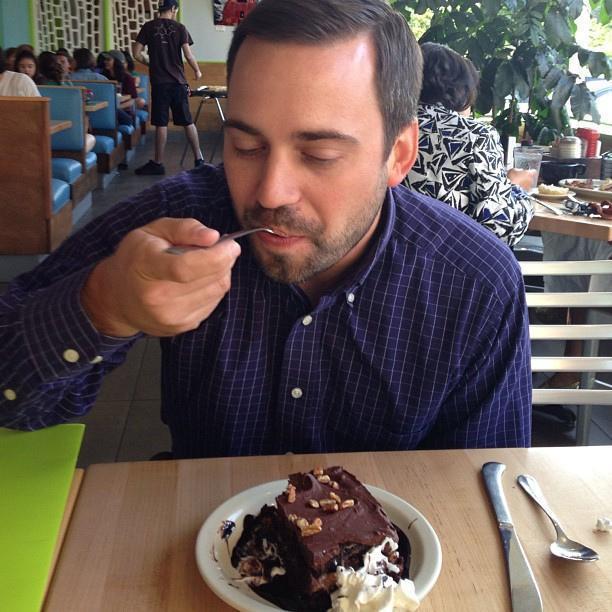How many people can be seen?
Give a very brief answer. 3. How many clocks are there?
Give a very brief answer. 0. 